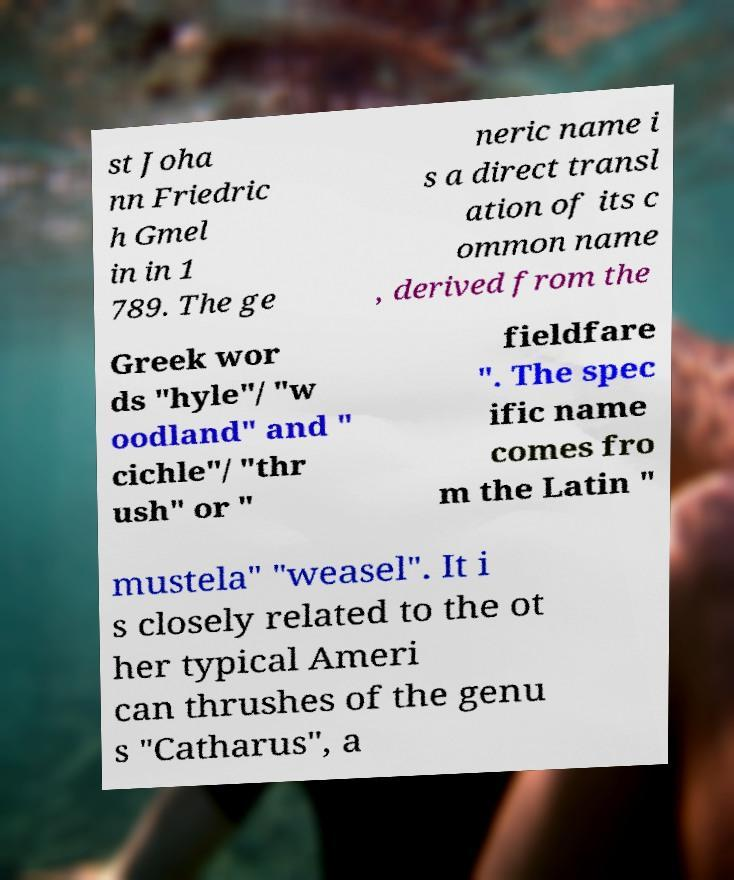I need the written content from this picture converted into text. Can you do that? st Joha nn Friedric h Gmel in in 1 789. The ge neric name i s a direct transl ation of its c ommon name , derived from the Greek wor ds "hyle"/ "w oodland" and " cichle"/ "thr ush" or " fieldfare ". The spec ific name comes fro m the Latin " mustela" "weasel". It i s closely related to the ot her typical Ameri can thrushes of the genu s "Catharus", a 